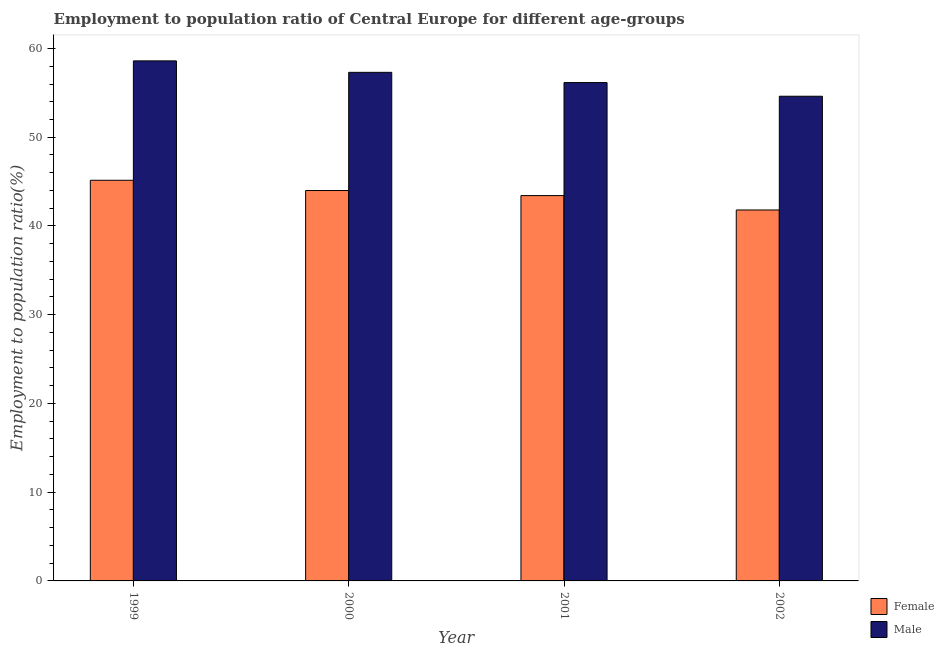How many different coloured bars are there?
Provide a succinct answer. 2. How many groups of bars are there?
Your answer should be very brief. 4. Are the number of bars per tick equal to the number of legend labels?
Your response must be concise. Yes. How many bars are there on the 3rd tick from the left?
Offer a terse response. 2. How many bars are there on the 1st tick from the right?
Offer a very short reply. 2. In how many cases, is the number of bars for a given year not equal to the number of legend labels?
Make the answer very short. 0. What is the employment to population ratio(male) in 2000?
Provide a succinct answer. 57.32. Across all years, what is the maximum employment to population ratio(female)?
Provide a succinct answer. 45.15. Across all years, what is the minimum employment to population ratio(female)?
Give a very brief answer. 41.8. In which year was the employment to population ratio(male) maximum?
Your response must be concise. 1999. What is the total employment to population ratio(female) in the graph?
Your response must be concise. 174.37. What is the difference between the employment to population ratio(male) in 1999 and that in 2002?
Offer a very short reply. 3.98. What is the difference between the employment to population ratio(female) in 2001 and the employment to population ratio(male) in 2002?
Your answer should be very brief. 1.62. What is the average employment to population ratio(female) per year?
Your answer should be very brief. 43.59. In how many years, is the employment to population ratio(male) greater than 14 %?
Offer a terse response. 4. What is the ratio of the employment to population ratio(male) in 1999 to that in 2000?
Give a very brief answer. 1.02. Is the employment to population ratio(male) in 2000 less than that in 2002?
Offer a very short reply. No. What is the difference between the highest and the second highest employment to population ratio(male)?
Your response must be concise. 1.29. What is the difference between the highest and the lowest employment to population ratio(female)?
Make the answer very short. 3.35. Is the sum of the employment to population ratio(male) in 2000 and 2001 greater than the maximum employment to population ratio(female) across all years?
Your answer should be compact. Yes. What does the 1st bar from the right in 2000 represents?
Your answer should be compact. Male. How many bars are there?
Give a very brief answer. 8. Are all the bars in the graph horizontal?
Your response must be concise. No. Are the values on the major ticks of Y-axis written in scientific E-notation?
Ensure brevity in your answer.  No. Does the graph contain any zero values?
Your answer should be very brief. No. Does the graph contain grids?
Your response must be concise. No. How are the legend labels stacked?
Ensure brevity in your answer.  Vertical. What is the title of the graph?
Your answer should be very brief. Employment to population ratio of Central Europe for different age-groups. What is the label or title of the Y-axis?
Keep it short and to the point. Employment to population ratio(%). What is the Employment to population ratio(%) of Female in 1999?
Your answer should be compact. 45.15. What is the Employment to population ratio(%) in Male in 1999?
Your answer should be compact. 58.61. What is the Employment to population ratio(%) in Female in 2000?
Keep it short and to the point. 43.99. What is the Employment to population ratio(%) in Male in 2000?
Ensure brevity in your answer.  57.32. What is the Employment to population ratio(%) in Female in 2001?
Provide a succinct answer. 43.43. What is the Employment to population ratio(%) of Male in 2001?
Offer a terse response. 56.16. What is the Employment to population ratio(%) of Female in 2002?
Keep it short and to the point. 41.8. What is the Employment to population ratio(%) of Male in 2002?
Your answer should be compact. 54.62. Across all years, what is the maximum Employment to population ratio(%) of Female?
Your response must be concise. 45.15. Across all years, what is the maximum Employment to population ratio(%) in Male?
Give a very brief answer. 58.61. Across all years, what is the minimum Employment to population ratio(%) of Female?
Ensure brevity in your answer.  41.8. Across all years, what is the minimum Employment to population ratio(%) in Male?
Give a very brief answer. 54.62. What is the total Employment to population ratio(%) of Female in the graph?
Provide a short and direct response. 174.37. What is the total Employment to population ratio(%) of Male in the graph?
Your answer should be very brief. 226.7. What is the difference between the Employment to population ratio(%) of Female in 1999 and that in 2000?
Ensure brevity in your answer.  1.16. What is the difference between the Employment to population ratio(%) of Male in 1999 and that in 2000?
Provide a short and direct response. 1.29. What is the difference between the Employment to population ratio(%) in Female in 1999 and that in 2001?
Provide a short and direct response. 1.73. What is the difference between the Employment to population ratio(%) in Male in 1999 and that in 2001?
Keep it short and to the point. 2.44. What is the difference between the Employment to population ratio(%) of Female in 1999 and that in 2002?
Offer a terse response. 3.35. What is the difference between the Employment to population ratio(%) in Male in 1999 and that in 2002?
Keep it short and to the point. 3.98. What is the difference between the Employment to population ratio(%) in Female in 2000 and that in 2001?
Provide a succinct answer. 0.57. What is the difference between the Employment to population ratio(%) of Male in 2000 and that in 2001?
Your response must be concise. 1.15. What is the difference between the Employment to population ratio(%) in Female in 2000 and that in 2002?
Provide a short and direct response. 2.19. What is the difference between the Employment to population ratio(%) in Male in 2000 and that in 2002?
Offer a very short reply. 2.69. What is the difference between the Employment to population ratio(%) of Female in 2001 and that in 2002?
Offer a very short reply. 1.62. What is the difference between the Employment to population ratio(%) of Male in 2001 and that in 2002?
Offer a very short reply. 1.54. What is the difference between the Employment to population ratio(%) in Female in 1999 and the Employment to population ratio(%) in Male in 2000?
Provide a succinct answer. -12.16. What is the difference between the Employment to population ratio(%) in Female in 1999 and the Employment to population ratio(%) in Male in 2001?
Provide a short and direct response. -11.01. What is the difference between the Employment to population ratio(%) of Female in 1999 and the Employment to population ratio(%) of Male in 2002?
Ensure brevity in your answer.  -9.47. What is the difference between the Employment to population ratio(%) in Female in 2000 and the Employment to population ratio(%) in Male in 2001?
Your response must be concise. -12.17. What is the difference between the Employment to population ratio(%) of Female in 2000 and the Employment to population ratio(%) of Male in 2002?
Your answer should be very brief. -10.63. What is the difference between the Employment to population ratio(%) in Female in 2001 and the Employment to population ratio(%) in Male in 2002?
Make the answer very short. -11.2. What is the average Employment to population ratio(%) of Female per year?
Provide a short and direct response. 43.59. What is the average Employment to population ratio(%) of Male per year?
Make the answer very short. 56.68. In the year 1999, what is the difference between the Employment to population ratio(%) in Female and Employment to population ratio(%) in Male?
Offer a terse response. -13.46. In the year 2000, what is the difference between the Employment to population ratio(%) of Female and Employment to population ratio(%) of Male?
Ensure brevity in your answer.  -13.32. In the year 2001, what is the difference between the Employment to population ratio(%) in Female and Employment to population ratio(%) in Male?
Offer a terse response. -12.74. In the year 2002, what is the difference between the Employment to population ratio(%) in Female and Employment to population ratio(%) in Male?
Your answer should be very brief. -12.82. What is the ratio of the Employment to population ratio(%) in Female in 1999 to that in 2000?
Your answer should be compact. 1.03. What is the ratio of the Employment to population ratio(%) of Male in 1999 to that in 2000?
Keep it short and to the point. 1.02. What is the ratio of the Employment to population ratio(%) of Female in 1999 to that in 2001?
Ensure brevity in your answer.  1.04. What is the ratio of the Employment to population ratio(%) of Male in 1999 to that in 2001?
Your response must be concise. 1.04. What is the ratio of the Employment to population ratio(%) in Female in 1999 to that in 2002?
Ensure brevity in your answer.  1.08. What is the ratio of the Employment to population ratio(%) in Male in 1999 to that in 2002?
Make the answer very short. 1.07. What is the ratio of the Employment to population ratio(%) of Female in 2000 to that in 2001?
Your answer should be compact. 1.01. What is the ratio of the Employment to population ratio(%) in Male in 2000 to that in 2001?
Give a very brief answer. 1.02. What is the ratio of the Employment to population ratio(%) in Female in 2000 to that in 2002?
Your response must be concise. 1.05. What is the ratio of the Employment to population ratio(%) of Male in 2000 to that in 2002?
Make the answer very short. 1.05. What is the ratio of the Employment to population ratio(%) in Female in 2001 to that in 2002?
Ensure brevity in your answer.  1.04. What is the ratio of the Employment to population ratio(%) in Male in 2001 to that in 2002?
Your answer should be compact. 1.03. What is the difference between the highest and the second highest Employment to population ratio(%) of Female?
Give a very brief answer. 1.16. What is the difference between the highest and the second highest Employment to population ratio(%) in Male?
Provide a short and direct response. 1.29. What is the difference between the highest and the lowest Employment to population ratio(%) of Female?
Provide a succinct answer. 3.35. What is the difference between the highest and the lowest Employment to population ratio(%) in Male?
Make the answer very short. 3.98. 